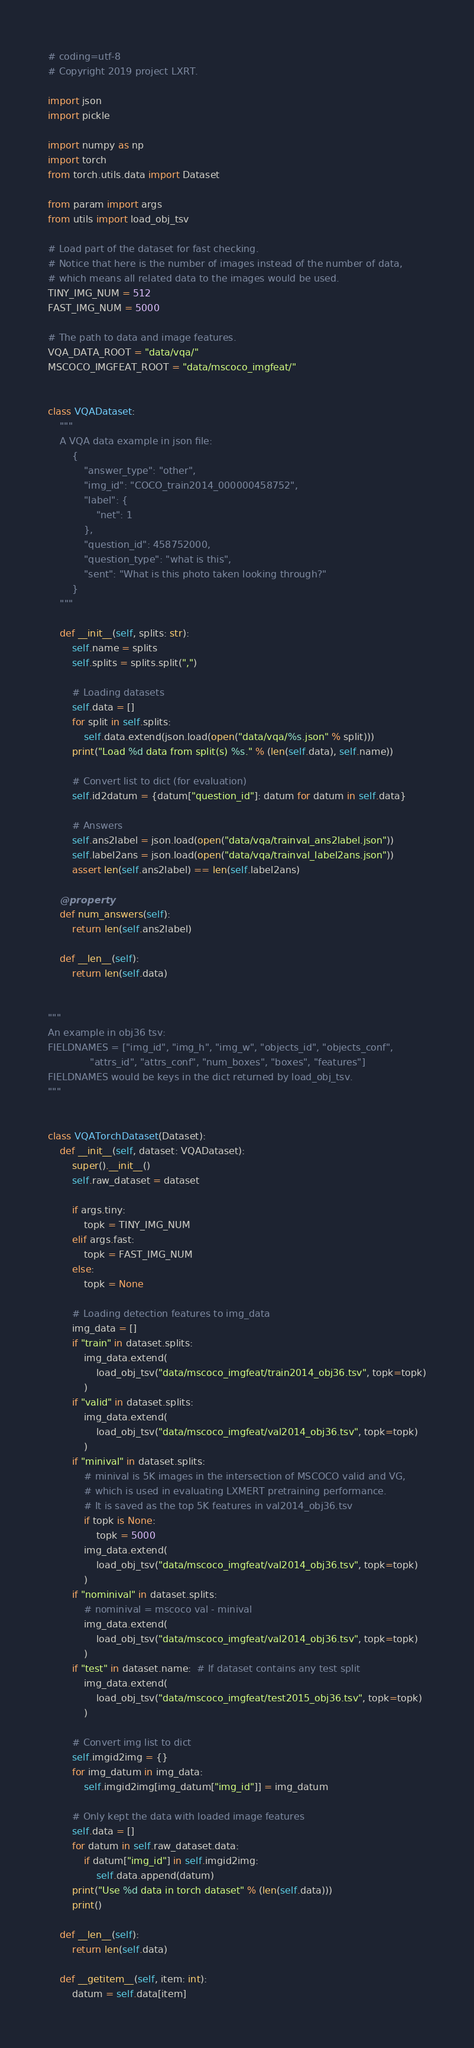<code> <loc_0><loc_0><loc_500><loc_500><_Python_># coding=utf-8
# Copyright 2019 project LXRT.

import json
import pickle

import numpy as np
import torch
from torch.utils.data import Dataset

from param import args
from utils import load_obj_tsv

# Load part of the dataset for fast checking.
# Notice that here is the number of images instead of the number of data,
# which means all related data to the images would be used.
TINY_IMG_NUM = 512
FAST_IMG_NUM = 5000

# The path to data and image features.
VQA_DATA_ROOT = "data/vqa/"
MSCOCO_IMGFEAT_ROOT = "data/mscoco_imgfeat/"


class VQADataset:
    """
    A VQA data example in json file:
        {
            "answer_type": "other",
            "img_id": "COCO_train2014_000000458752",
            "label": {
                "net": 1
            },
            "question_id": 458752000,
            "question_type": "what is this",
            "sent": "What is this photo taken looking through?"
        }
    """

    def __init__(self, splits: str):
        self.name = splits
        self.splits = splits.split(",")

        # Loading datasets
        self.data = []
        for split in self.splits:
            self.data.extend(json.load(open("data/vqa/%s.json" % split)))
        print("Load %d data from split(s) %s." % (len(self.data), self.name))

        # Convert list to dict (for evaluation)
        self.id2datum = {datum["question_id"]: datum for datum in self.data}

        # Answers
        self.ans2label = json.load(open("data/vqa/trainval_ans2label.json"))
        self.label2ans = json.load(open("data/vqa/trainval_label2ans.json"))
        assert len(self.ans2label) == len(self.label2ans)

    @property
    def num_answers(self):
        return len(self.ans2label)

    def __len__(self):
        return len(self.data)


"""
An example in obj36 tsv:
FIELDNAMES = ["img_id", "img_h", "img_w", "objects_id", "objects_conf",
              "attrs_id", "attrs_conf", "num_boxes", "boxes", "features"]
FIELDNAMES would be keys in the dict returned by load_obj_tsv.
"""


class VQATorchDataset(Dataset):
    def __init__(self, dataset: VQADataset):
        super().__init__()
        self.raw_dataset = dataset

        if args.tiny:
            topk = TINY_IMG_NUM
        elif args.fast:
            topk = FAST_IMG_NUM
        else:
            topk = None

        # Loading detection features to img_data
        img_data = []
        if "train" in dataset.splits:
            img_data.extend(
                load_obj_tsv("data/mscoco_imgfeat/train2014_obj36.tsv", topk=topk)
            )
        if "valid" in dataset.splits:
            img_data.extend(
                load_obj_tsv("data/mscoco_imgfeat/val2014_obj36.tsv", topk=topk)
            )
        if "minival" in dataset.splits:
            # minival is 5K images in the intersection of MSCOCO valid and VG,
            # which is used in evaluating LXMERT pretraining performance.
            # It is saved as the top 5K features in val2014_obj36.tsv
            if topk is None:
                topk = 5000
            img_data.extend(
                load_obj_tsv("data/mscoco_imgfeat/val2014_obj36.tsv", topk=topk)
            )
        if "nominival" in dataset.splits:
            # nominival = mscoco val - minival
            img_data.extend(
                load_obj_tsv("data/mscoco_imgfeat/val2014_obj36.tsv", topk=topk)
            )
        if "test" in dataset.name:  # If dataset contains any test split
            img_data.extend(
                load_obj_tsv("data/mscoco_imgfeat/test2015_obj36.tsv", topk=topk)
            )

        # Convert img list to dict
        self.imgid2img = {}
        for img_datum in img_data:
            self.imgid2img[img_datum["img_id"]] = img_datum

        # Only kept the data with loaded image features
        self.data = []
        for datum in self.raw_dataset.data:
            if datum["img_id"] in self.imgid2img:
                self.data.append(datum)
        print("Use %d data in torch dataset" % (len(self.data)))
        print()

    def __len__(self):
        return len(self.data)

    def __getitem__(self, item: int):
        datum = self.data[item]
</code> 